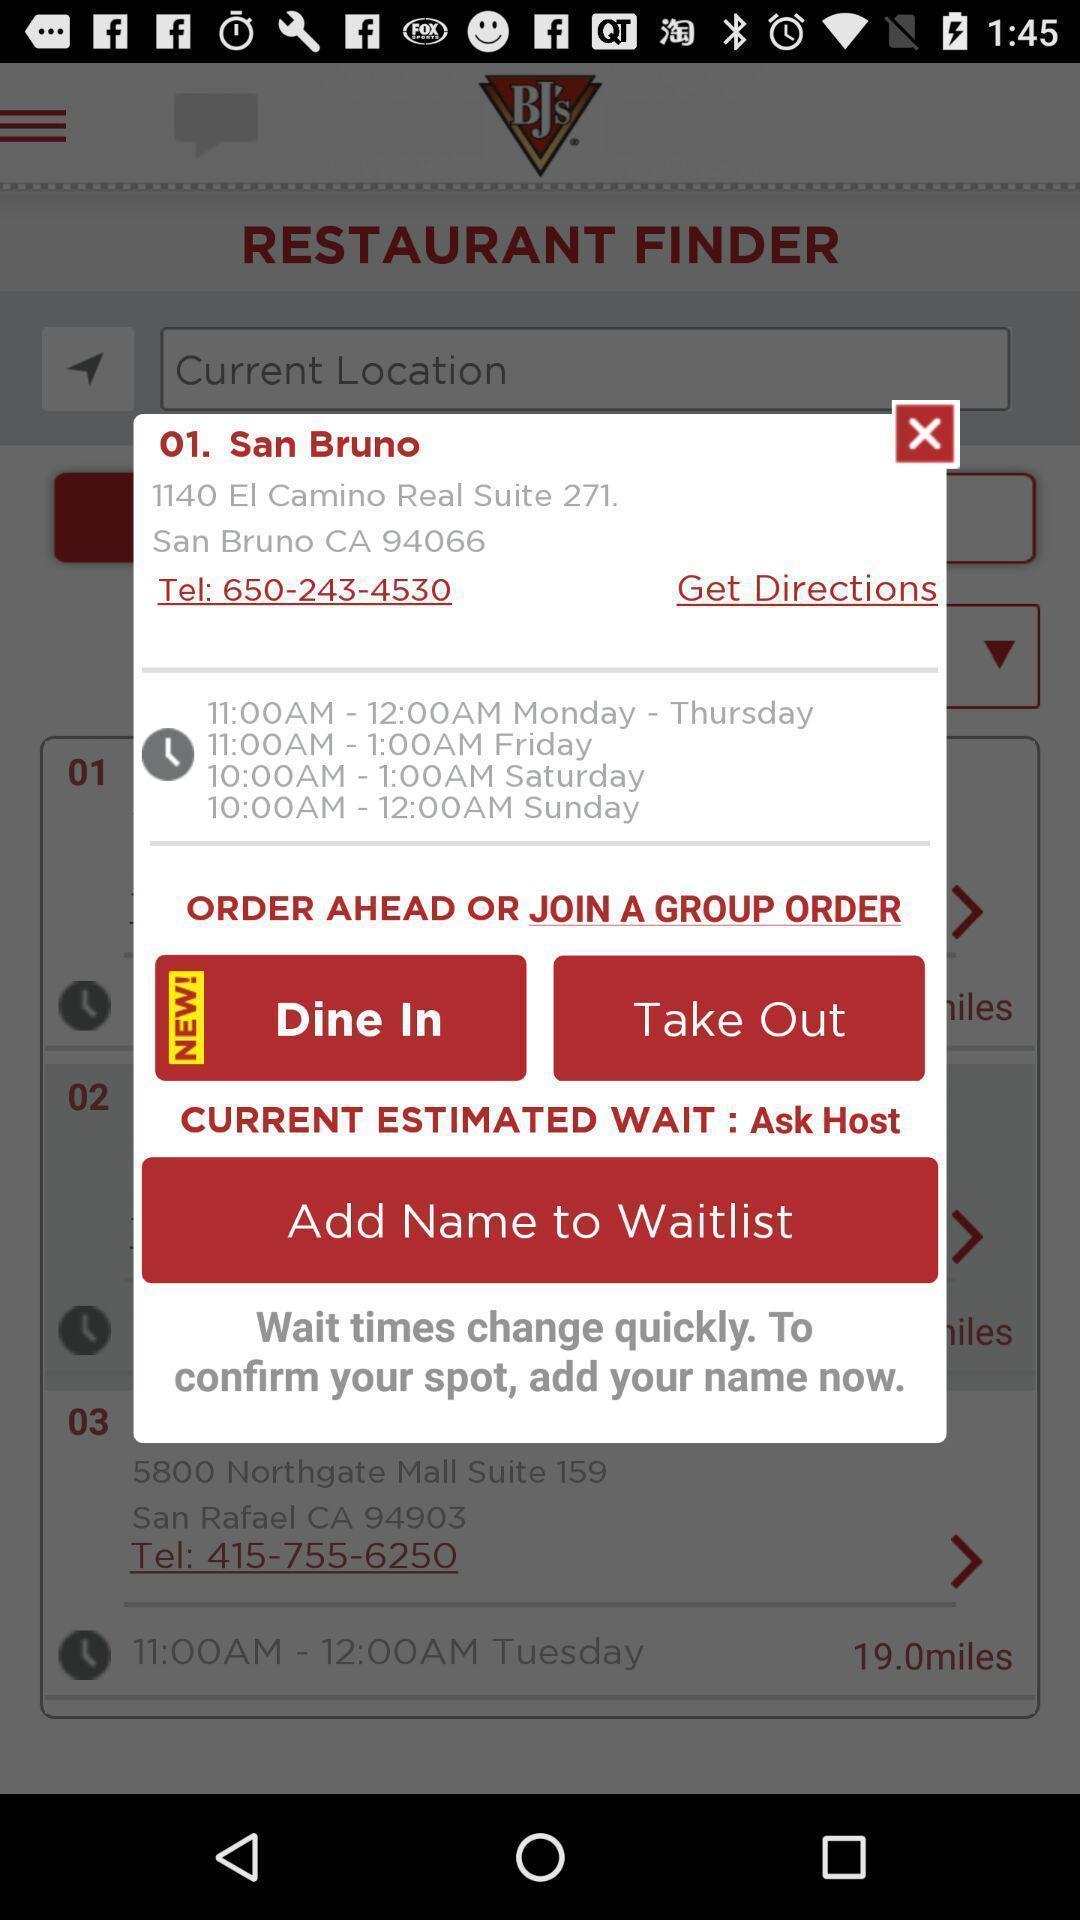Describe the visual elements of this screenshot. Pop-up message about the details of a restaurant. 